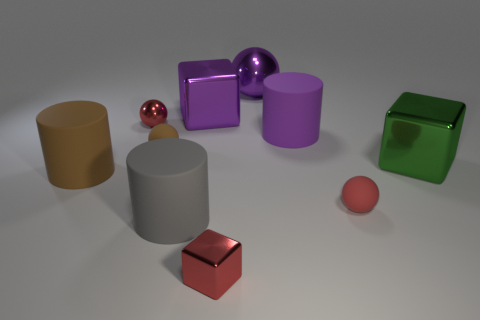Subtract all gray rubber cylinders. How many cylinders are left? 2 Subtract 1 cylinders. How many cylinders are left? 2 Subtract all green blocks. How many blocks are left? 2 Subtract all blocks. How many objects are left? 7 Subtract all tiny red metal objects. Subtract all small red shiny things. How many objects are left? 6 Add 8 big purple balls. How many big purple balls are left? 9 Add 2 tiny red rubber cylinders. How many tiny red rubber cylinders exist? 2 Subtract 0 green balls. How many objects are left? 10 Subtract all green blocks. Subtract all red spheres. How many blocks are left? 2 Subtract all gray spheres. How many purple cubes are left? 1 